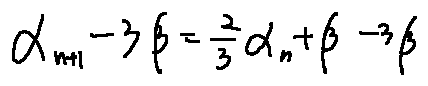<formula> <loc_0><loc_0><loc_500><loc_500>\alpha _ { n + 1 } - 3 \beta = \frac { 2 } { 3 } \alpha _ { n } + \beta - 3 \beta</formula> 